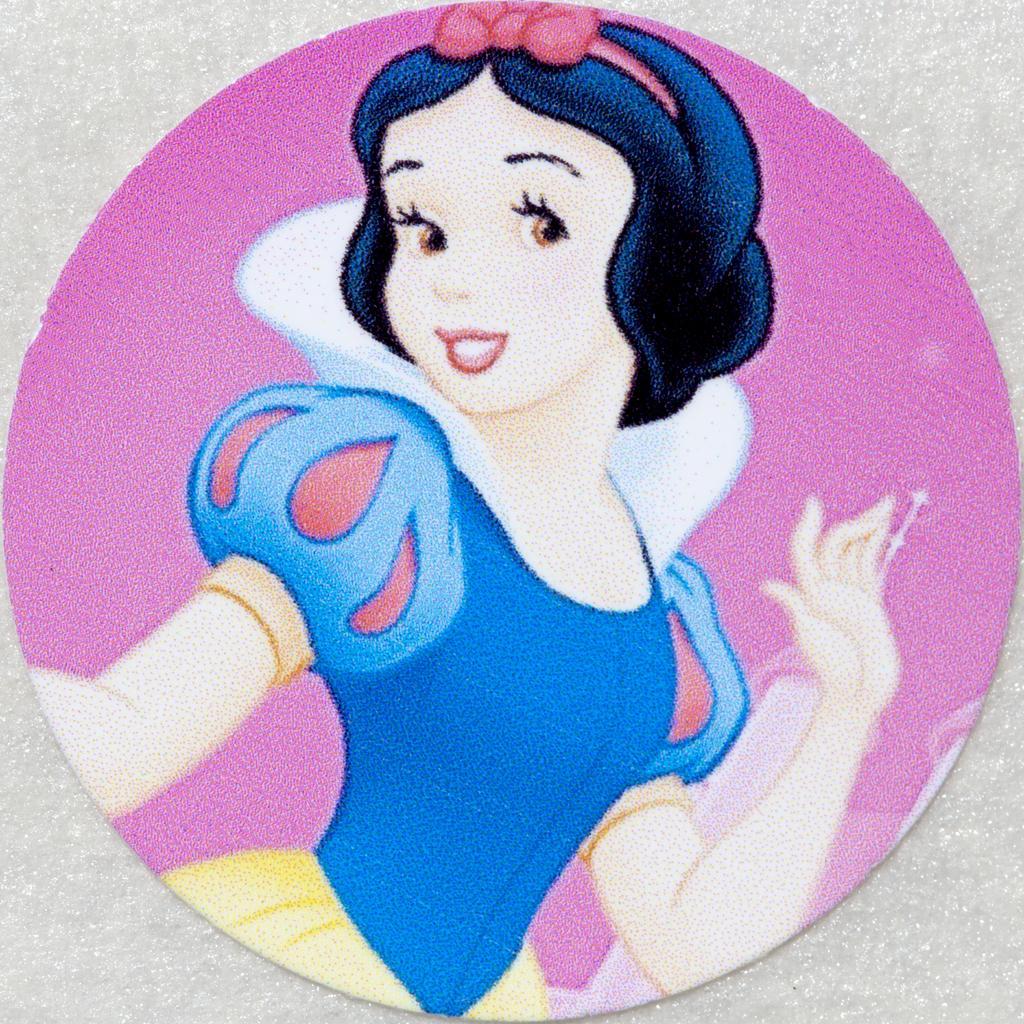Can you describe this image briefly? In this image there is a painting. In this image, we can see painting of a girl. In the background, we can pink color and white color. 